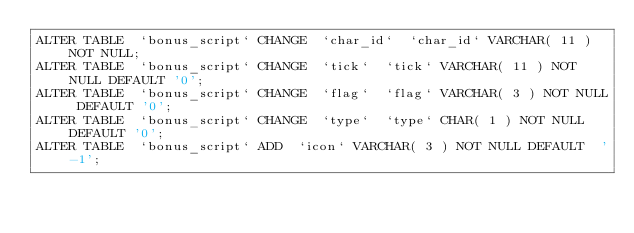<code> <loc_0><loc_0><loc_500><loc_500><_SQL_>ALTER TABLE  `bonus_script` CHANGE  `char_id`  `char_id` VARCHAR( 11 ) NOT NULL;
ALTER TABLE  `bonus_script` CHANGE  `tick`  `tick` VARCHAR( 11 ) NOT NULL DEFAULT '0';
ALTER TABLE  `bonus_script` CHANGE  `flag`  `flag` VARCHAR( 3 ) NOT NULL DEFAULT '0';
ALTER TABLE  `bonus_script` CHANGE  `type`  `type` CHAR( 1 ) NOT NULL DEFAULT '0';
ALTER TABLE  `bonus_script` ADD  `icon` VARCHAR( 3 ) NOT NULL DEFAULT  '-1';
</code> 